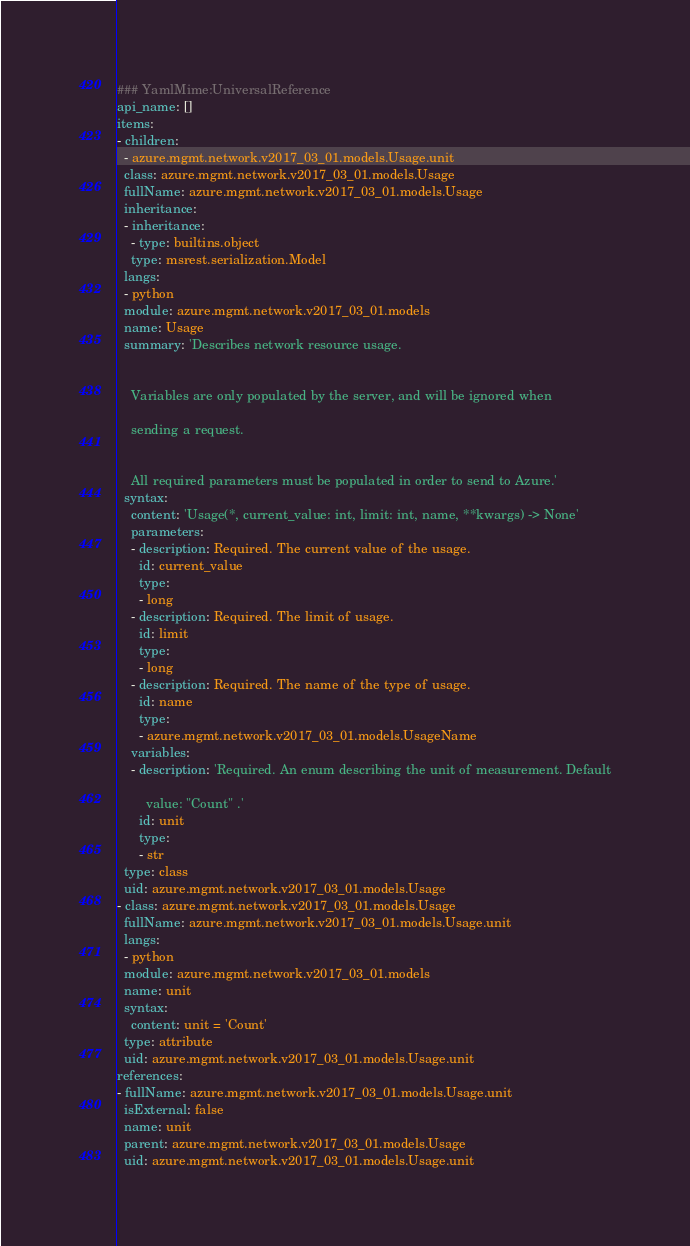<code> <loc_0><loc_0><loc_500><loc_500><_YAML_>### YamlMime:UniversalReference
api_name: []
items:
- children:
  - azure.mgmt.network.v2017_03_01.models.Usage.unit
  class: azure.mgmt.network.v2017_03_01.models.Usage
  fullName: azure.mgmt.network.v2017_03_01.models.Usage
  inheritance:
  - inheritance:
    - type: builtins.object
    type: msrest.serialization.Model
  langs:
  - python
  module: azure.mgmt.network.v2017_03_01.models
  name: Usage
  summary: 'Describes network resource usage.


    Variables are only populated by the server, and will be ignored when

    sending a request.


    All required parameters must be populated in order to send to Azure.'
  syntax:
    content: 'Usage(*, current_value: int, limit: int, name, **kwargs) -> None'
    parameters:
    - description: Required. The current value of the usage.
      id: current_value
      type:
      - long
    - description: Required. The limit of usage.
      id: limit
      type:
      - long
    - description: Required. The name of the type of usage.
      id: name
      type:
      - azure.mgmt.network.v2017_03_01.models.UsageName
    variables:
    - description: 'Required. An enum describing the unit of measurement. Default

        value: "Count" .'
      id: unit
      type:
      - str
  type: class
  uid: azure.mgmt.network.v2017_03_01.models.Usage
- class: azure.mgmt.network.v2017_03_01.models.Usage
  fullName: azure.mgmt.network.v2017_03_01.models.Usage.unit
  langs:
  - python
  module: azure.mgmt.network.v2017_03_01.models
  name: unit
  syntax:
    content: unit = 'Count'
  type: attribute
  uid: azure.mgmt.network.v2017_03_01.models.Usage.unit
references:
- fullName: azure.mgmt.network.v2017_03_01.models.Usage.unit
  isExternal: false
  name: unit
  parent: azure.mgmt.network.v2017_03_01.models.Usage
  uid: azure.mgmt.network.v2017_03_01.models.Usage.unit
</code> 